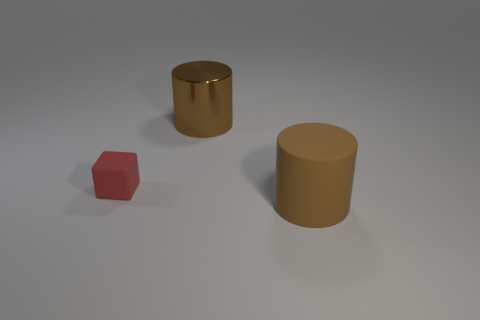Are there the same number of big objects that are to the left of the large matte object and big brown shiny cylinders left of the small red matte cube?
Offer a terse response. No. What is the big brown thing that is in front of the brown shiny thing on the left side of the big brown rubber cylinder made of?
Provide a short and direct response. Rubber. How many things are either purple metallic blocks or large brown cylinders in front of the tiny object?
Provide a short and direct response. 1. There is a brown thing that is the same material as the red block; what is its size?
Your response must be concise. Large. Are there more brown shiny objects on the right side of the large brown rubber thing than things?
Provide a short and direct response. No. What is the size of the thing that is to the right of the red rubber thing and behind the brown rubber cylinder?
Provide a short and direct response. Large. There is another brown object that is the same shape as the large metal thing; what is its material?
Give a very brief answer. Rubber. There is a object that is behind the red matte thing; does it have the same size as the small block?
Your response must be concise. No. There is a object that is left of the large matte object and right of the red cube; what color is it?
Provide a short and direct response. Brown. What number of brown rubber things are right of the large cylinder behind the small matte object?
Provide a succinct answer. 1. 